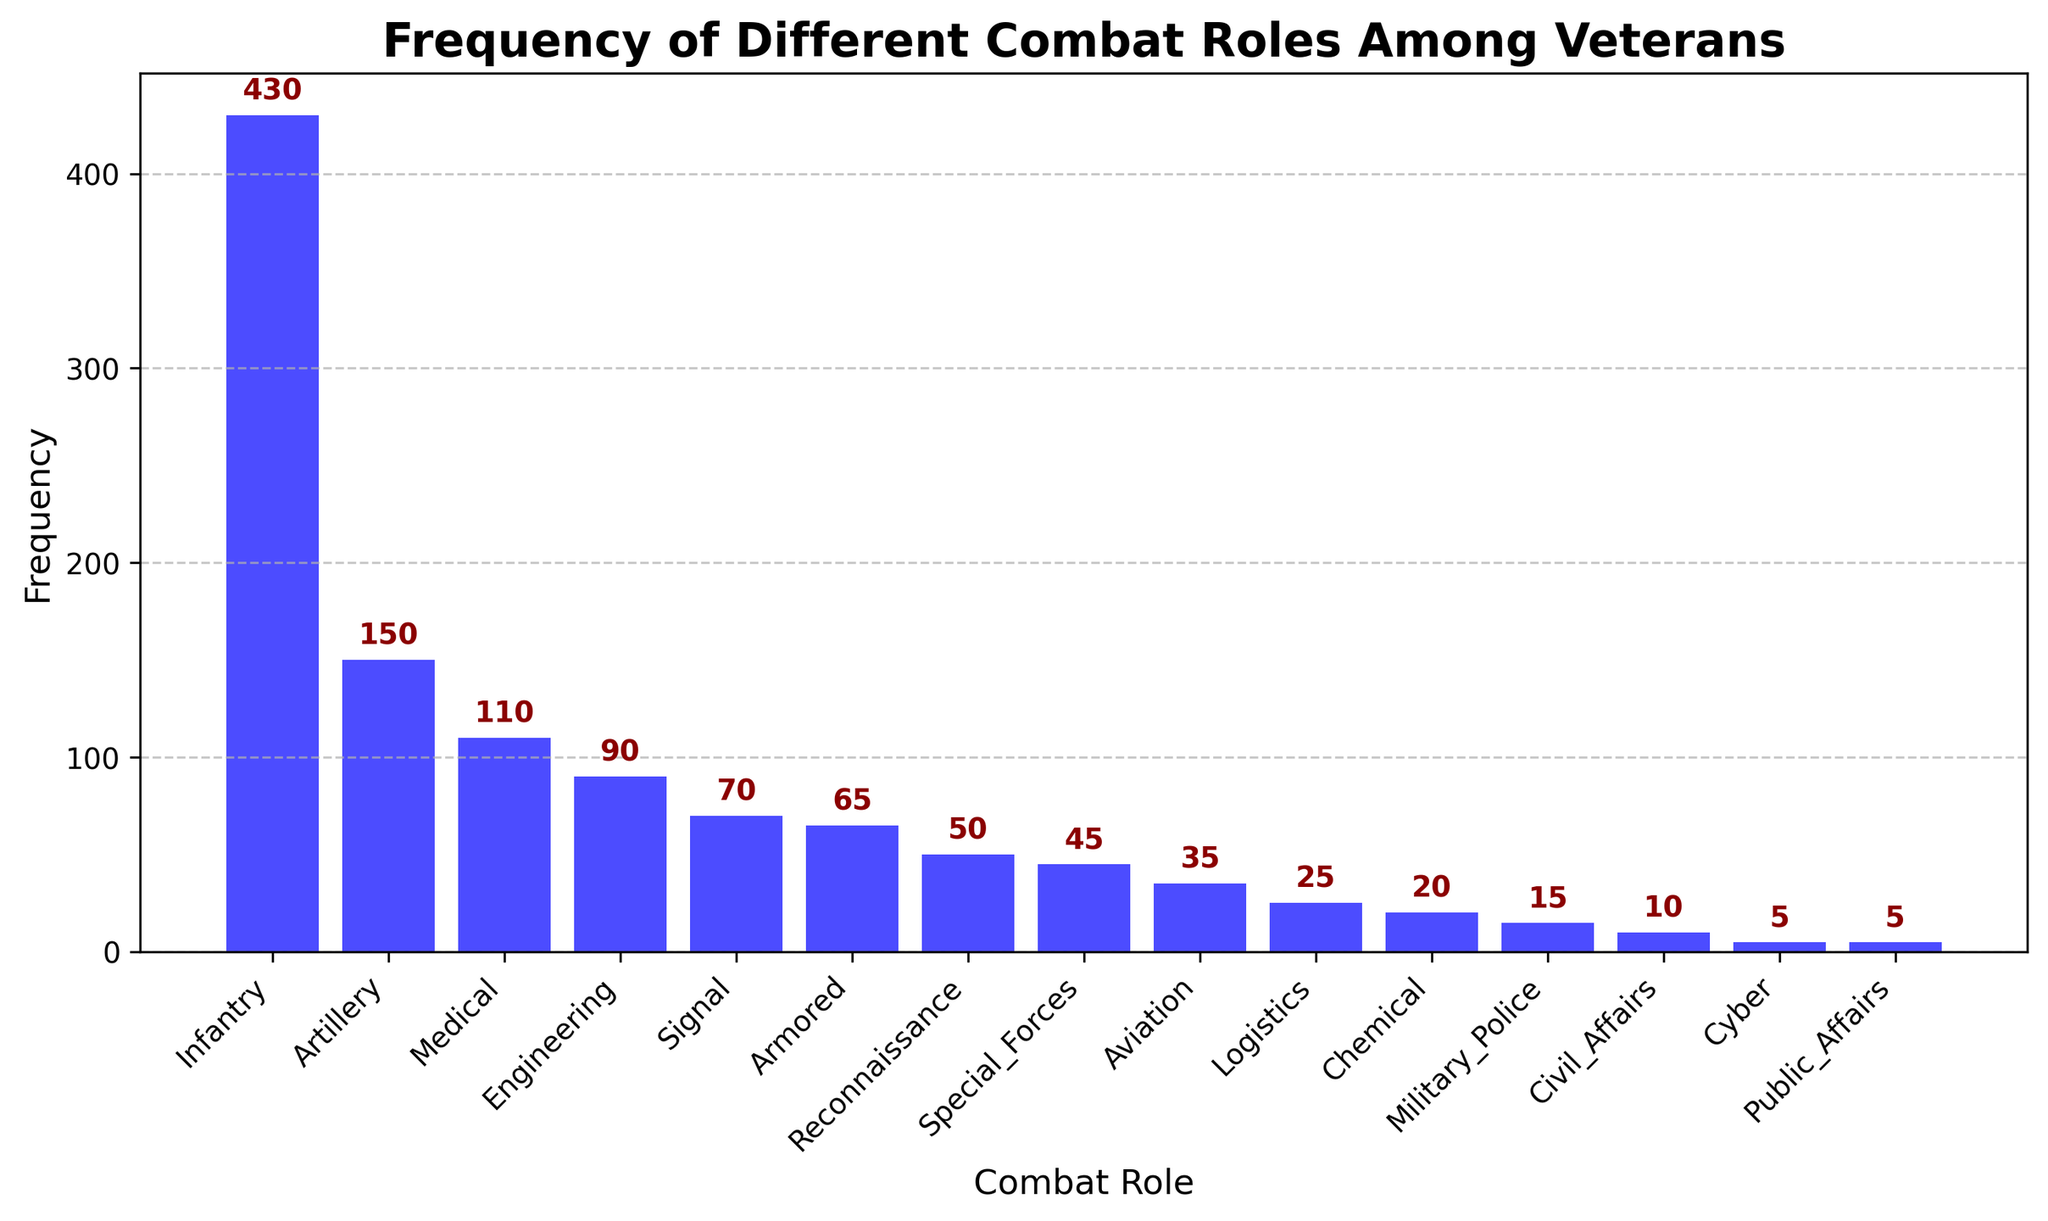What's the most frequent combat role among veterans? The bar for Infantry is the tallest in the histogram, indicating it has the highest frequency. Therefore, Infantry is the most frequent combat role among veterans.
Answer: Infantry Which combat role has the least frequency? The bars for Cyber and Public Affairs are the shortest, each representing a frequency of 5. Therefore, these two combat roles share the least frequency.
Answer: Cyber, Public Affairs How much more frequent is Infantry than Artillery? The frequency of Infantry is 430 and the frequency of Artillery is 150. The difference between them is 430 - 150 = 280.
Answer: 280 What's the combined frequency of Medical, Engineering, and Signal roles? To find the combined frequency, sum their individual frequencies: Medical (110) + Engineering (90) + Signal (70) = 110 + 90 + 70 = 270.
Answer: 270 Is the frequency of Reconnaissance higher than that of Special Forces? In the histogram, Reconnaissance has a frequency of 50 while Special Forces has a frequency of 45. Since 50 is greater than 45, the frequency of Reconnaissance is higher than that of Special Forces.
Answer: Yes What is the average frequency of the top three combat roles? The top three combat roles by frequency are Infantry (430), Artillery (150), and Medical (110). The average is calculated as (430 + 150 + 110) / 3 = 690 / 3 = 230.
Answer: 230 How many combat roles have frequencies greater than 50? From the histogram, the roles with frequencies greater than 50 are Infantry, Artillery, Medical, and Engineering. This makes a total of 4 roles.
Answer: 4 Which combat role has the closest frequency to that of Signal? Signal has a frequency of 70. The closest frequency is that of Armored with a frequency of 65, which is a difference of 5.
Answer: Armored What is the ratio of the frequency of Artillery to that of Chemical? The frequency of Artillery is 150 and the frequency of Chemical is 20. The ratio is calculated as 150 / 20 = 7.5.
Answer: 7.5 